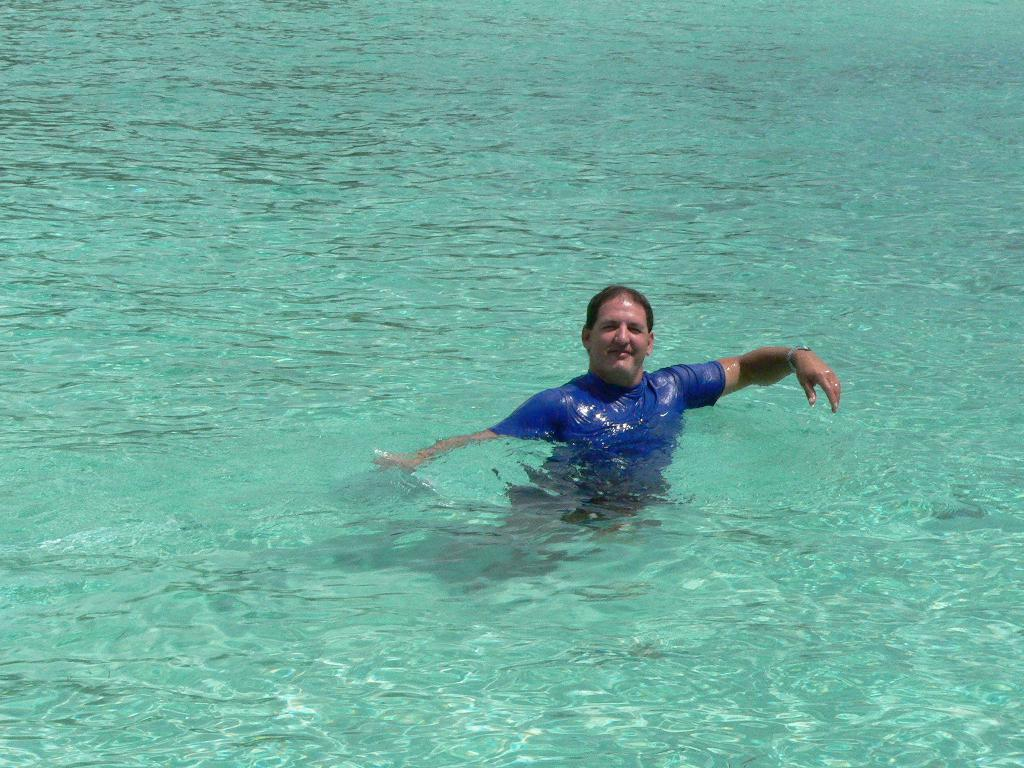Who is the person in the image? There is a man in the image. What is the man doing in the image? The man is swimming in the image. Where is the man swimming? The swimming is taking place in a pool. What type of jar can be seen floating in the pool with the man? There is no jar present in the image; it only features a man swimming in a pool. 